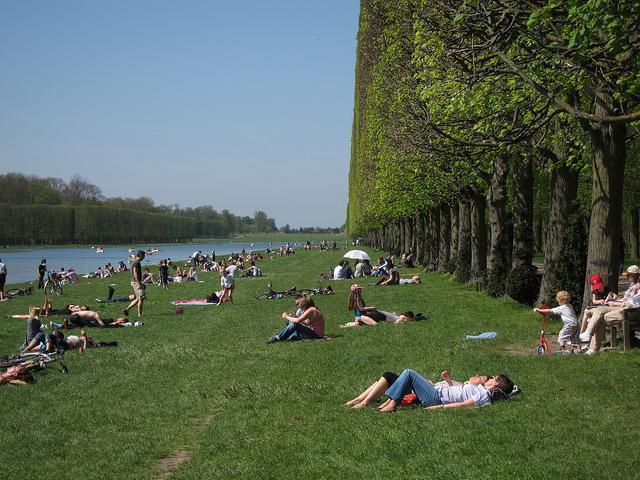Why are these people laying here?
Select the correct answer and articulate reasoning with the following format: 'Answer: answer
Rationale: rationale.'
Options: Hungry, hiding, tired, good weather. Answer: good weather.
Rationale: It is a pleasant looking day outside so it's logical to assume that the people are laying outside in the grass like this because they're enjoying the good weather. 